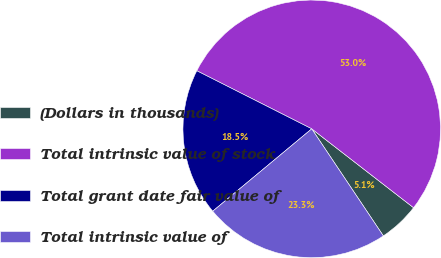<chart> <loc_0><loc_0><loc_500><loc_500><pie_chart><fcel>(Dollars in thousands)<fcel>Total intrinsic value of stock<fcel>Total grant date fair value of<fcel>Total intrinsic value of<nl><fcel>5.13%<fcel>53.04%<fcel>18.49%<fcel>23.34%<nl></chart> 